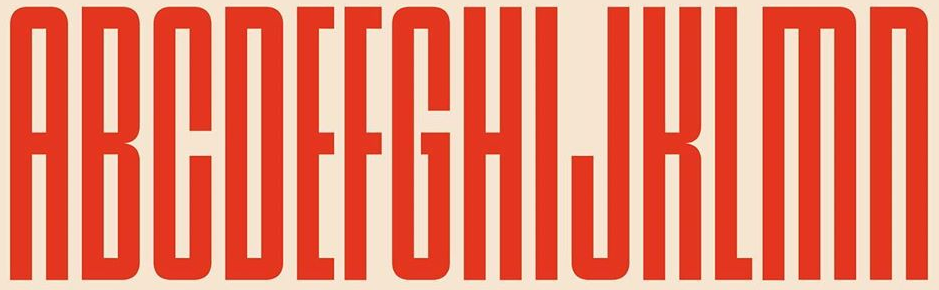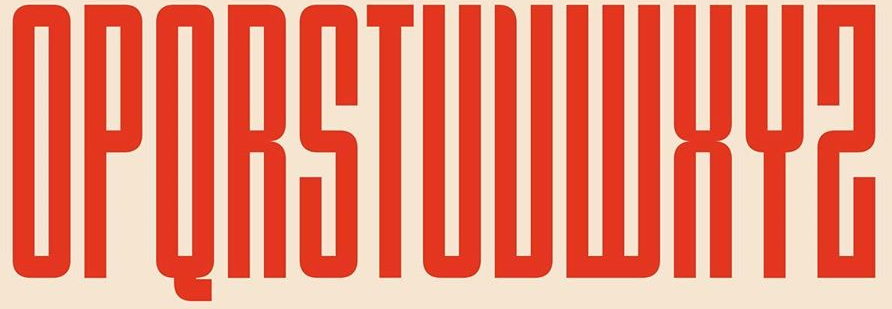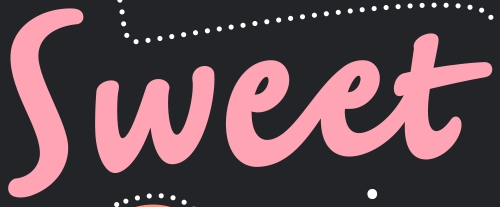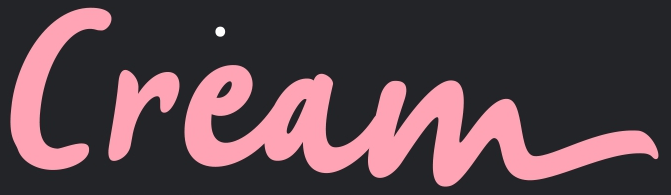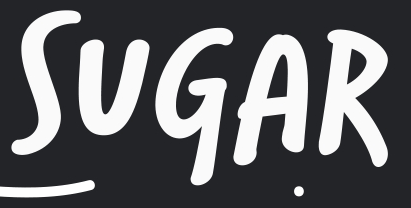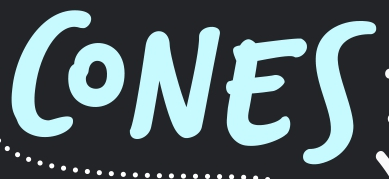What words can you see in these images in sequence, separated by a semicolon? ABCDEFGHIJKLMN; OPQRSTUVWXYZ; Sweet; Cream; SUGAR; CONES 